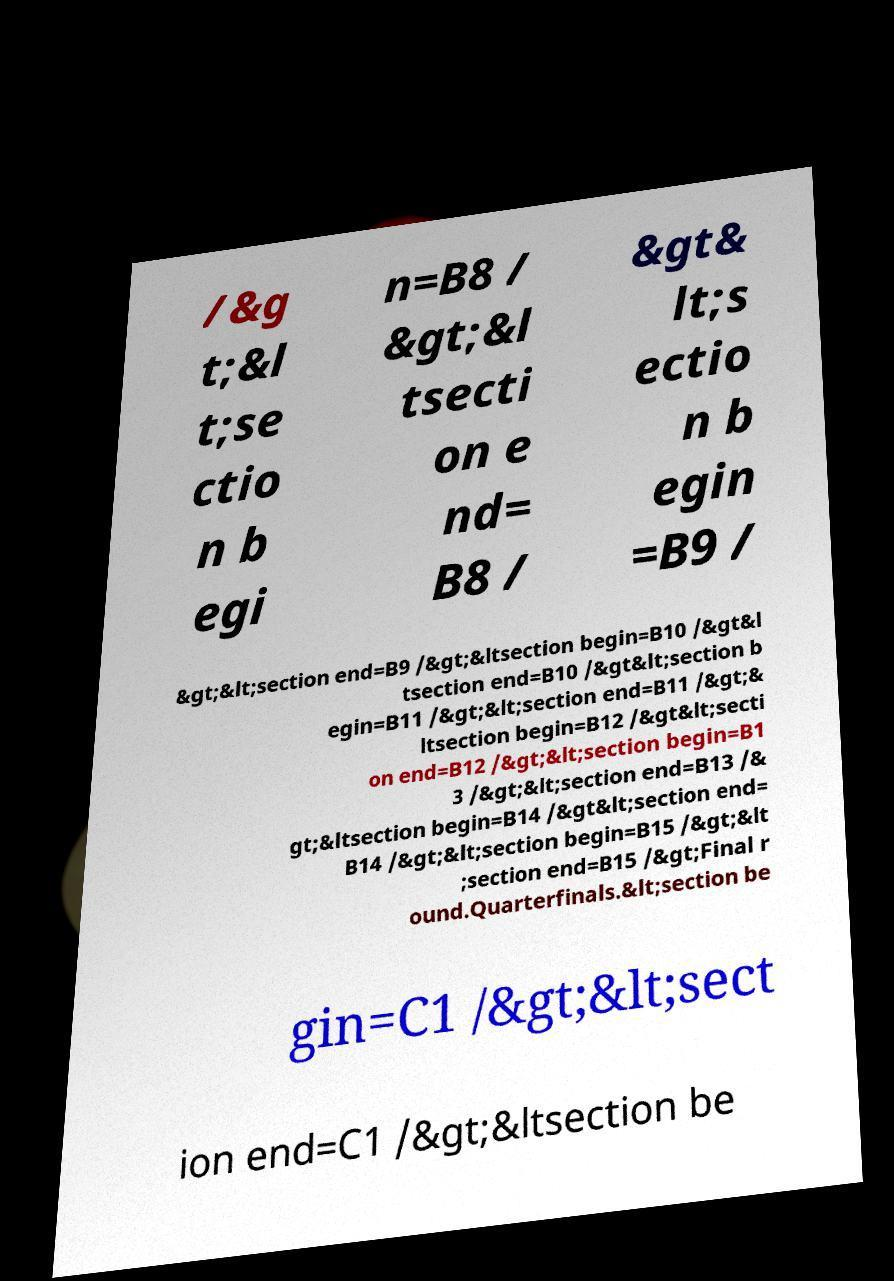Can you read and provide the text displayed in the image?This photo seems to have some interesting text. Can you extract and type it out for me? /&g t;&l t;se ctio n b egi n=B8 / &gt;&l tsecti on e nd= B8 / &gt& lt;s ectio n b egin =B9 / &gt;&lt;section end=B9 /&gt;&ltsection begin=B10 /&gt&l tsection end=B10 /&gt&lt;section b egin=B11 /&gt;&lt;section end=B11 /&gt;& ltsection begin=B12 /&gt&lt;secti on end=B12 /&gt;&lt;section begin=B1 3 /&gt;&lt;section end=B13 /& gt;&ltsection begin=B14 /&gt&lt;section end= B14 /&gt;&lt;section begin=B15 /&gt;&lt ;section end=B15 /&gt;Final r ound.Quarterfinals.&lt;section be gin=C1 /&gt;&lt;sect ion end=C1 /&gt;&ltsection be 